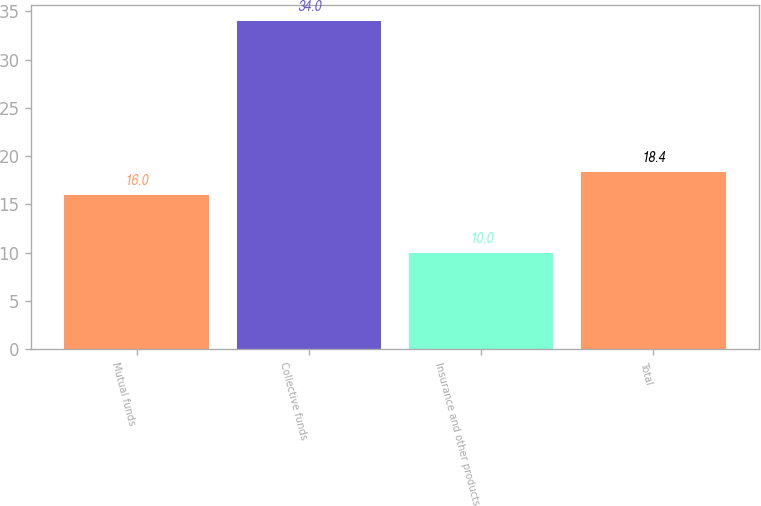Convert chart to OTSL. <chart><loc_0><loc_0><loc_500><loc_500><bar_chart><fcel>Mutual funds<fcel>Collective funds<fcel>Insurance and other products<fcel>Total<nl><fcel>16<fcel>34<fcel>10<fcel>18.4<nl></chart> 